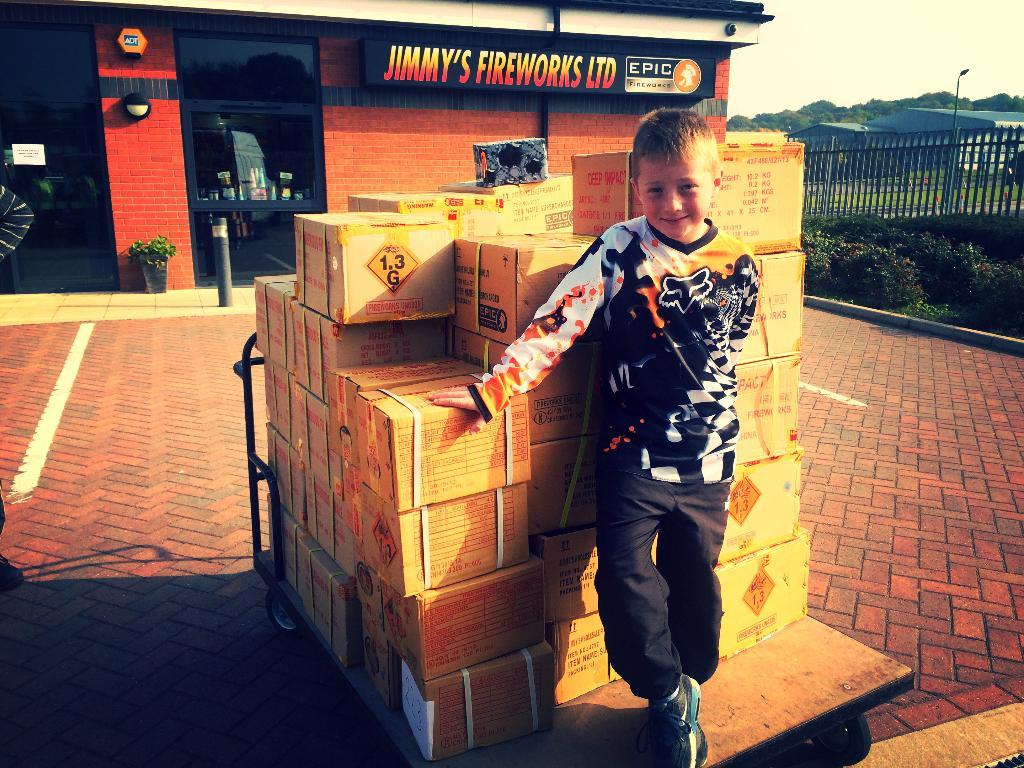<image>
Write a terse but informative summary of the picture. A small blonde boy is standing in front of boxes of fireworks at Jimmy's fireworks LTD. 